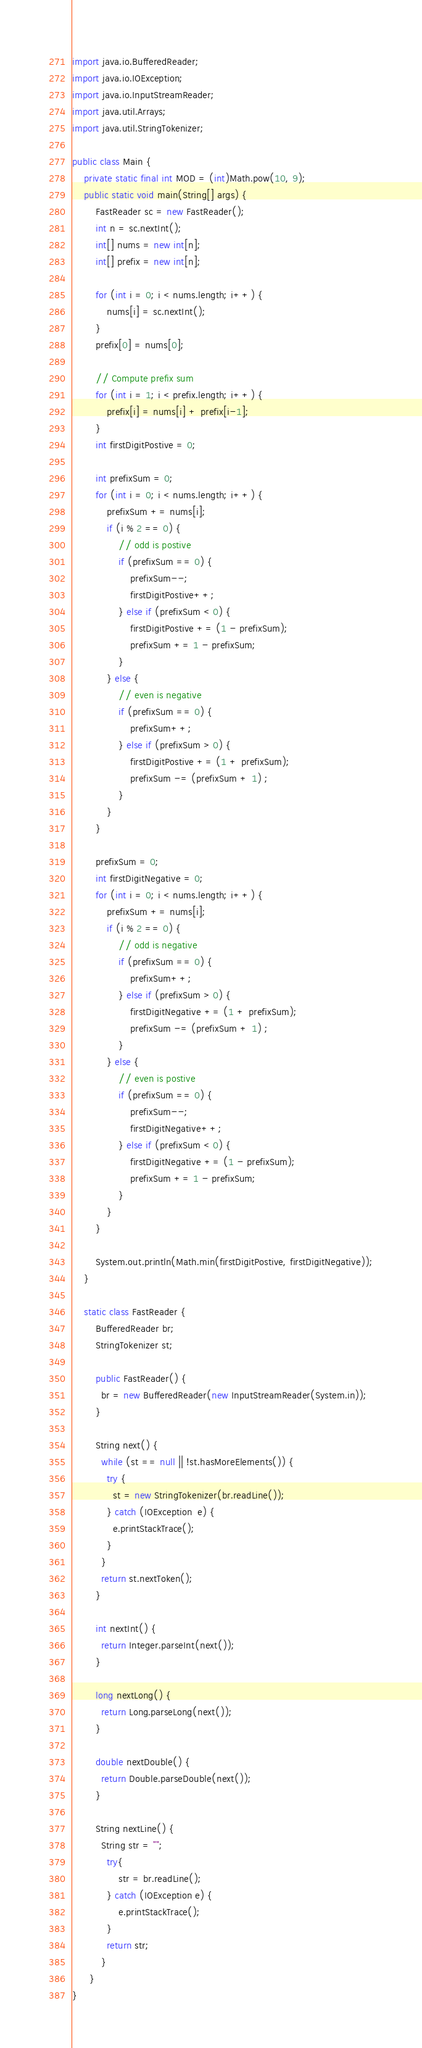<code> <loc_0><loc_0><loc_500><loc_500><_Java_>
import java.io.BufferedReader;
import java.io.IOException;
import java.io.InputStreamReader;
import java.util.Arrays;
import java.util.StringTokenizer;

public class Main {
	private static final int MOD = (int)Math.pow(10, 9);
	public static void main(String[] args) {
		FastReader sc = new FastReader();
		int n = sc.nextInt();
		int[] nums = new int[n];
		int[] prefix = new int[n];
		
		for (int i = 0; i < nums.length; i++) {
			nums[i] = sc.nextInt();
		}
		prefix[0] = nums[0];
		
		// Compute prefix sum
		for (int i = 1; i < prefix.length; i++) {
			prefix[i] = nums[i] + prefix[i-1];
		}
		int firstDigitPostive = 0;

		int prefixSum = 0;
		for (int i = 0; i < nums.length; i++) {
			prefixSum += nums[i];
			if (i % 2 == 0) {
				// odd is postive
				if (prefixSum == 0) {
					prefixSum--;
					firstDigitPostive++;
				} else if (prefixSum < 0) {
					firstDigitPostive += (1 - prefixSum);
					prefixSum += 1 - prefixSum;
				}
			} else {
				// even is negative
				if (prefixSum == 0) {
					prefixSum++;
				} else if (prefixSum > 0) {
					firstDigitPostive += (1 + prefixSum);
					prefixSum -= (prefixSum + 1) ;
				}
			}
		}
		
		prefixSum = 0;
		int firstDigitNegative = 0;
		for (int i = 0; i < nums.length; i++) {
			prefixSum += nums[i];
			if (i % 2 == 0) {
				// odd is negative
				if (prefixSum == 0) {
					prefixSum++;
				} else if (prefixSum > 0) {
					firstDigitNegative += (1 + prefixSum);
					prefixSum -= (prefixSum + 1) ;
				}
			} else {
				// even is postive
				if (prefixSum == 0) {
					prefixSum--;
					firstDigitNegative++;
				} else if (prefixSum < 0) {
					firstDigitNegative += (1 - prefixSum);
					prefixSum += 1 - prefixSum;
				}
			}
		}
		
		System.out.println(Math.min(firstDigitPostive, firstDigitNegative));
	}

    static class FastReader {
	    BufferedReader br;
	    StringTokenizer st;
	
	    public FastReader() {
	      br = new BufferedReader(new InputStreamReader(System.in));
	    }
	  
	    String next() { 
	      while (st == null || !st.hasMoreElements()) {
	        try {
	          st = new StringTokenizer(br.readLine());
	        } catch (IOException  e) {
	          e.printStackTrace();
	        }
	      }
	      return st.nextToken();
	    }
	
	    int nextInt() {
	      return Integer.parseInt(next());
	    }
	
	    long nextLong() {
	      return Long.parseLong(next());
	    }
	
	    double nextDouble() { 
	      return Double.parseDouble(next());
	    }
	
	    String nextLine() {
	      String str = "";
	        try{
	            str = br.readLine();
	        } catch (IOException e) {
	            e.printStackTrace();
	        }
	        return str;
	      }
	  }
}
</code> 